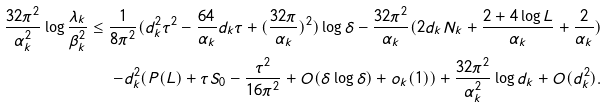Convert formula to latex. <formula><loc_0><loc_0><loc_500><loc_500>\frac { 3 2 \pi ^ { 2 } } { \alpha _ { k } ^ { 2 } } \log \frac { \lambda _ { k } } { \beta _ { k } ^ { 2 } } \leq \frac { 1 } { 8 \pi ^ { 2 } } ( d _ { k } ^ { 2 } \tau ^ { 2 } - \frac { 6 4 } { \alpha _ { k } } d _ { k } \tau + ( \frac { 3 2 \pi } { \alpha _ { k } } ) ^ { 2 } ) \log \delta - \frac { 3 2 \pi ^ { 2 } } { \alpha _ { k } } ( 2 d _ { k } N _ { k } + \frac { 2 + 4 \log L } { \alpha _ { k } } + \frac { 2 } { \alpha _ { k } } ) \\ - d _ { k } ^ { 2 } ( P ( L ) + \tau S _ { 0 } - \frac { \tau ^ { 2 } } { 1 6 \pi ^ { 2 } } + O ( \delta \log \delta ) + o _ { k } ( 1 ) ) + \frac { 3 2 \pi ^ { 2 } } { \alpha _ { k } ^ { 2 } } \log d _ { k } + O ( d _ { k } ^ { 2 } ) .</formula> 